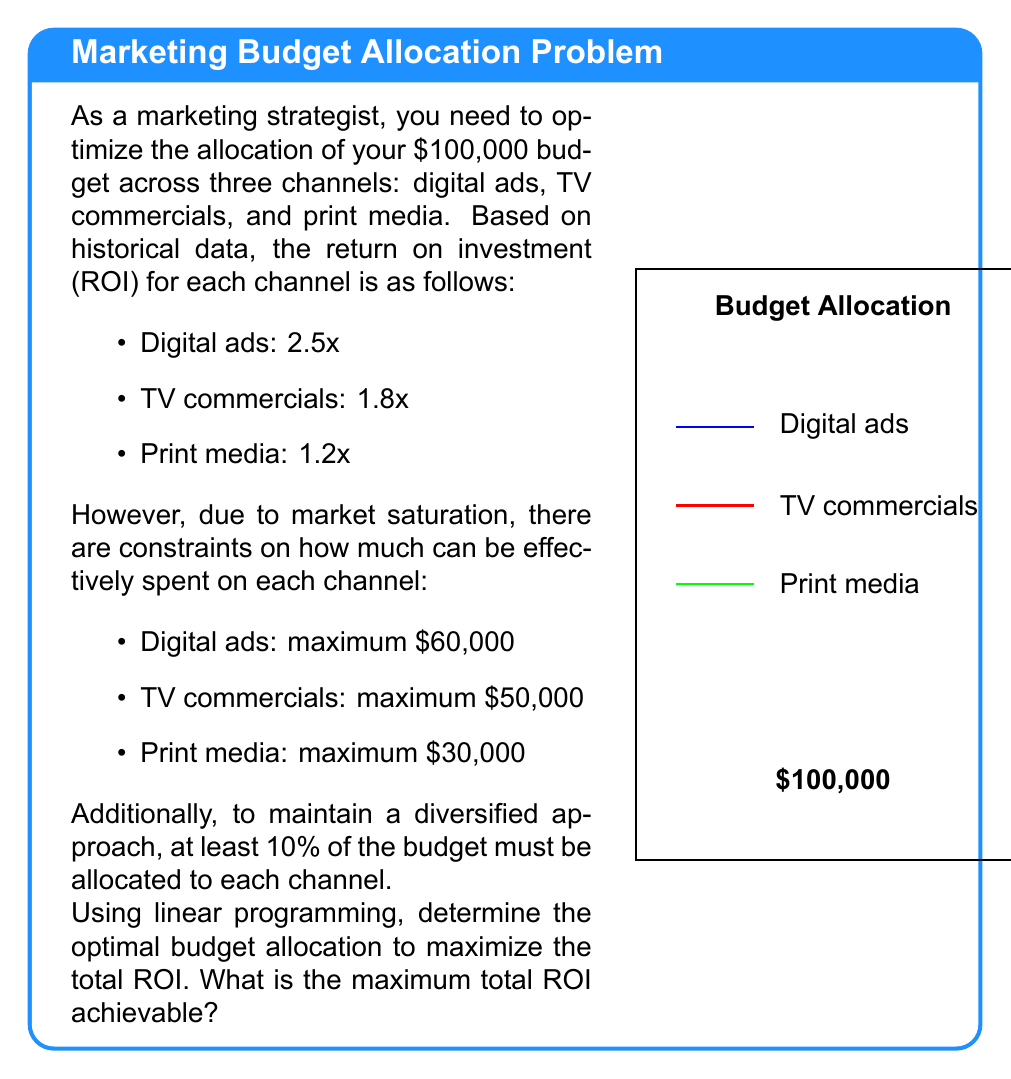Provide a solution to this math problem. Let's solve this step-by-step using linear programming:

1) Define variables:
   $x$ = amount spent on digital ads
   $y$ = amount spent on TV commercials
   $z$ = amount spent on print media

2) Objective function (to maximize):
   $\text{ROI} = 2.5x + 1.8y + 1.2z$

3) Constraints:
   a) Budget constraint: $x + y + z = 100,000$
   b) Maximum constraints:
      $x \leq 60,000$
      $y \leq 50,000$
      $z \leq 30,000$
   c) Minimum 10% constraints:
      $x \geq 10,000$
      $y \geq 10,000$
      $z \geq 10,000$
   d) Non-negativity: $x, y, z \geq 0$

4) Solving the linear programming problem:
   Given the constraints, we can deduce that the optimal solution will allocate the maximum possible to the highest ROI channel (digital ads), then to the second highest (TV commercials), and the remainder to print media.

5) Optimal allocation:
   Digital ads: $x = 60,000$ (maximum allowed)
   TV commercials: $y = 30,000$ (to meet budget constraint)
   Print media: $z = 10,000$ (minimum required)

6) Calculate the maximum ROI:
   $\text{ROI} = 2.5(60,000) + 1.8(30,000) + 1.2(10,000)$
               $= 150,000 + 54,000 + 12,000$
               $= 216,000$

Therefore, the maximum achievable ROI is $216,000, which is 2.16 times the initial budget.
Answer: $216,000 